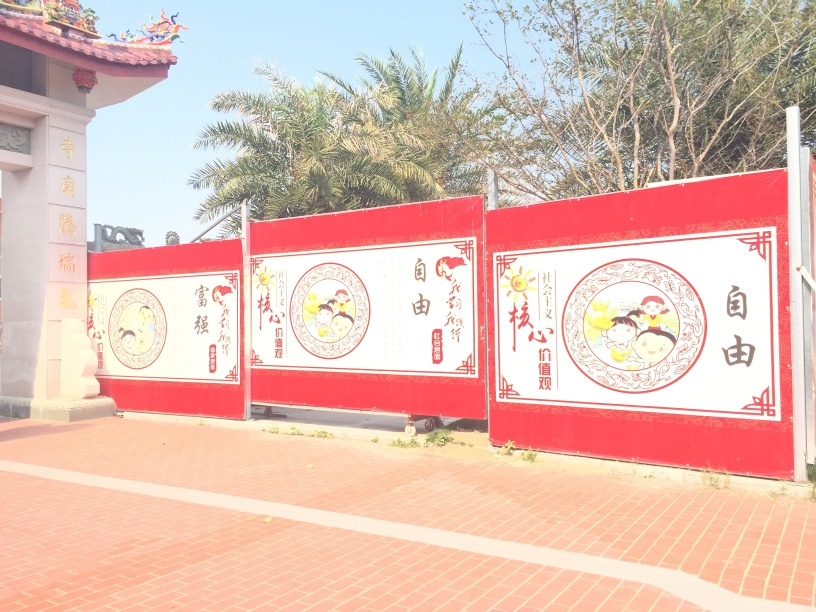What might be the purpose of such colorful panels in this location? Colorful panels like these are often used for decorative purposes and to convey messages or stories. In this context, they are likely meant to educate, celebrate, and honor cultural heritage. They could also be marking a specific event or festival, serving both as a point of attraction and a storytelling medium to pass on traditions and values to observers. 